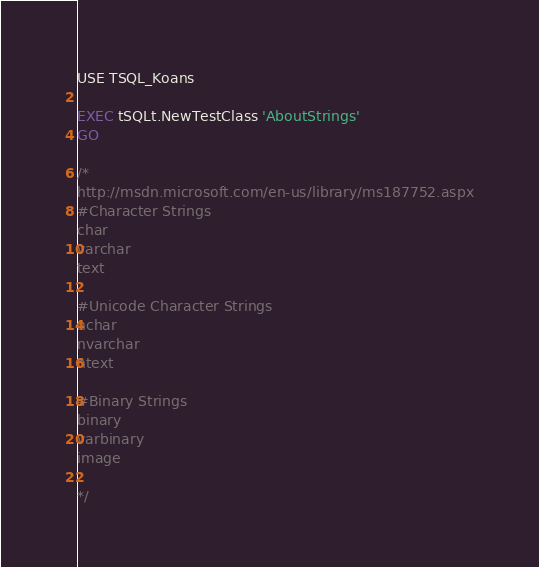Convert code to text. <code><loc_0><loc_0><loc_500><loc_500><_SQL_>USE TSQL_Koans

EXEC tSQLt.NewTestClass 'AboutStrings'
GO

/*
http://msdn.microsoft.com/en-us/library/ms187752.aspx
#Character Strings
char
varchar
text
 
#Unicode Character Strings
nchar
nvarchar
ntext
 
#Binary Strings
binary
varbinary
image
 
*/</code> 